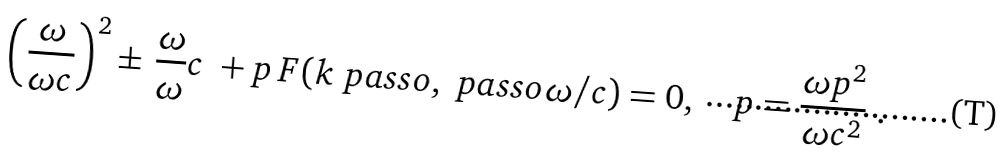Convert formula to latex. <formula><loc_0><loc_0><loc_500><loc_500>\left ( \frac { \omega } { \omega c } \right ) ^ { 2 } \pm \, \frac { \omega } { \omega } c \ + p \, F ( k \ p a s s o , \ p a s s o \omega / c ) = 0 , \quad p = \frac { \omega p ^ { 2 } } { \omega c ^ { 2 } } \ .</formula> 